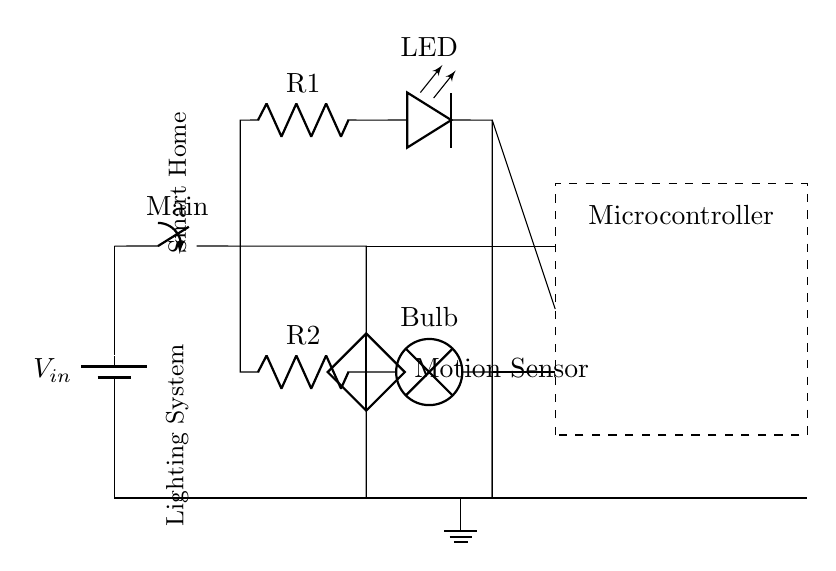What type of circuit is this? This circuit is a hybrid circuit that integrates both LED and traditional bulbs, allowing for different lighting technologies to function together. The presence of a LED component and a traditional bulb indicates this classification.
Answer: Hybrid What is the main component controlling the lighting? The microcontroller is the central part of the circuit that handles the automation and control of the lighting system, as shown by the dashed rectangle labeled "Microcontroller."
Answer: Microcontroller How many branches does the circuit have? There are two distinct branches in the circuit: one for the LED and one for the traditional bulb, which can be seen diverging from the main switch.
Answer: Two What is the role of the motion sensor in this circuit? The motion sensor is used to detect movement and likely controls when the lighting system is activated or deactivated, showing its function connected to the main switch and the microcontroller.
Answer: Activation What component is used for the LED in this circuit? The circuit uses a light-emitting diode, which is represented as "LED," to provide efficient lighting as part of the LED branch of the circuit.
Answer: LED Which resistor is associated with the traditional bulb? The resistor labeled "R2" is connected in series with the traditional bulb, indicating it is responsible for current regulation in that branch of the circuit.
Answer: R2 